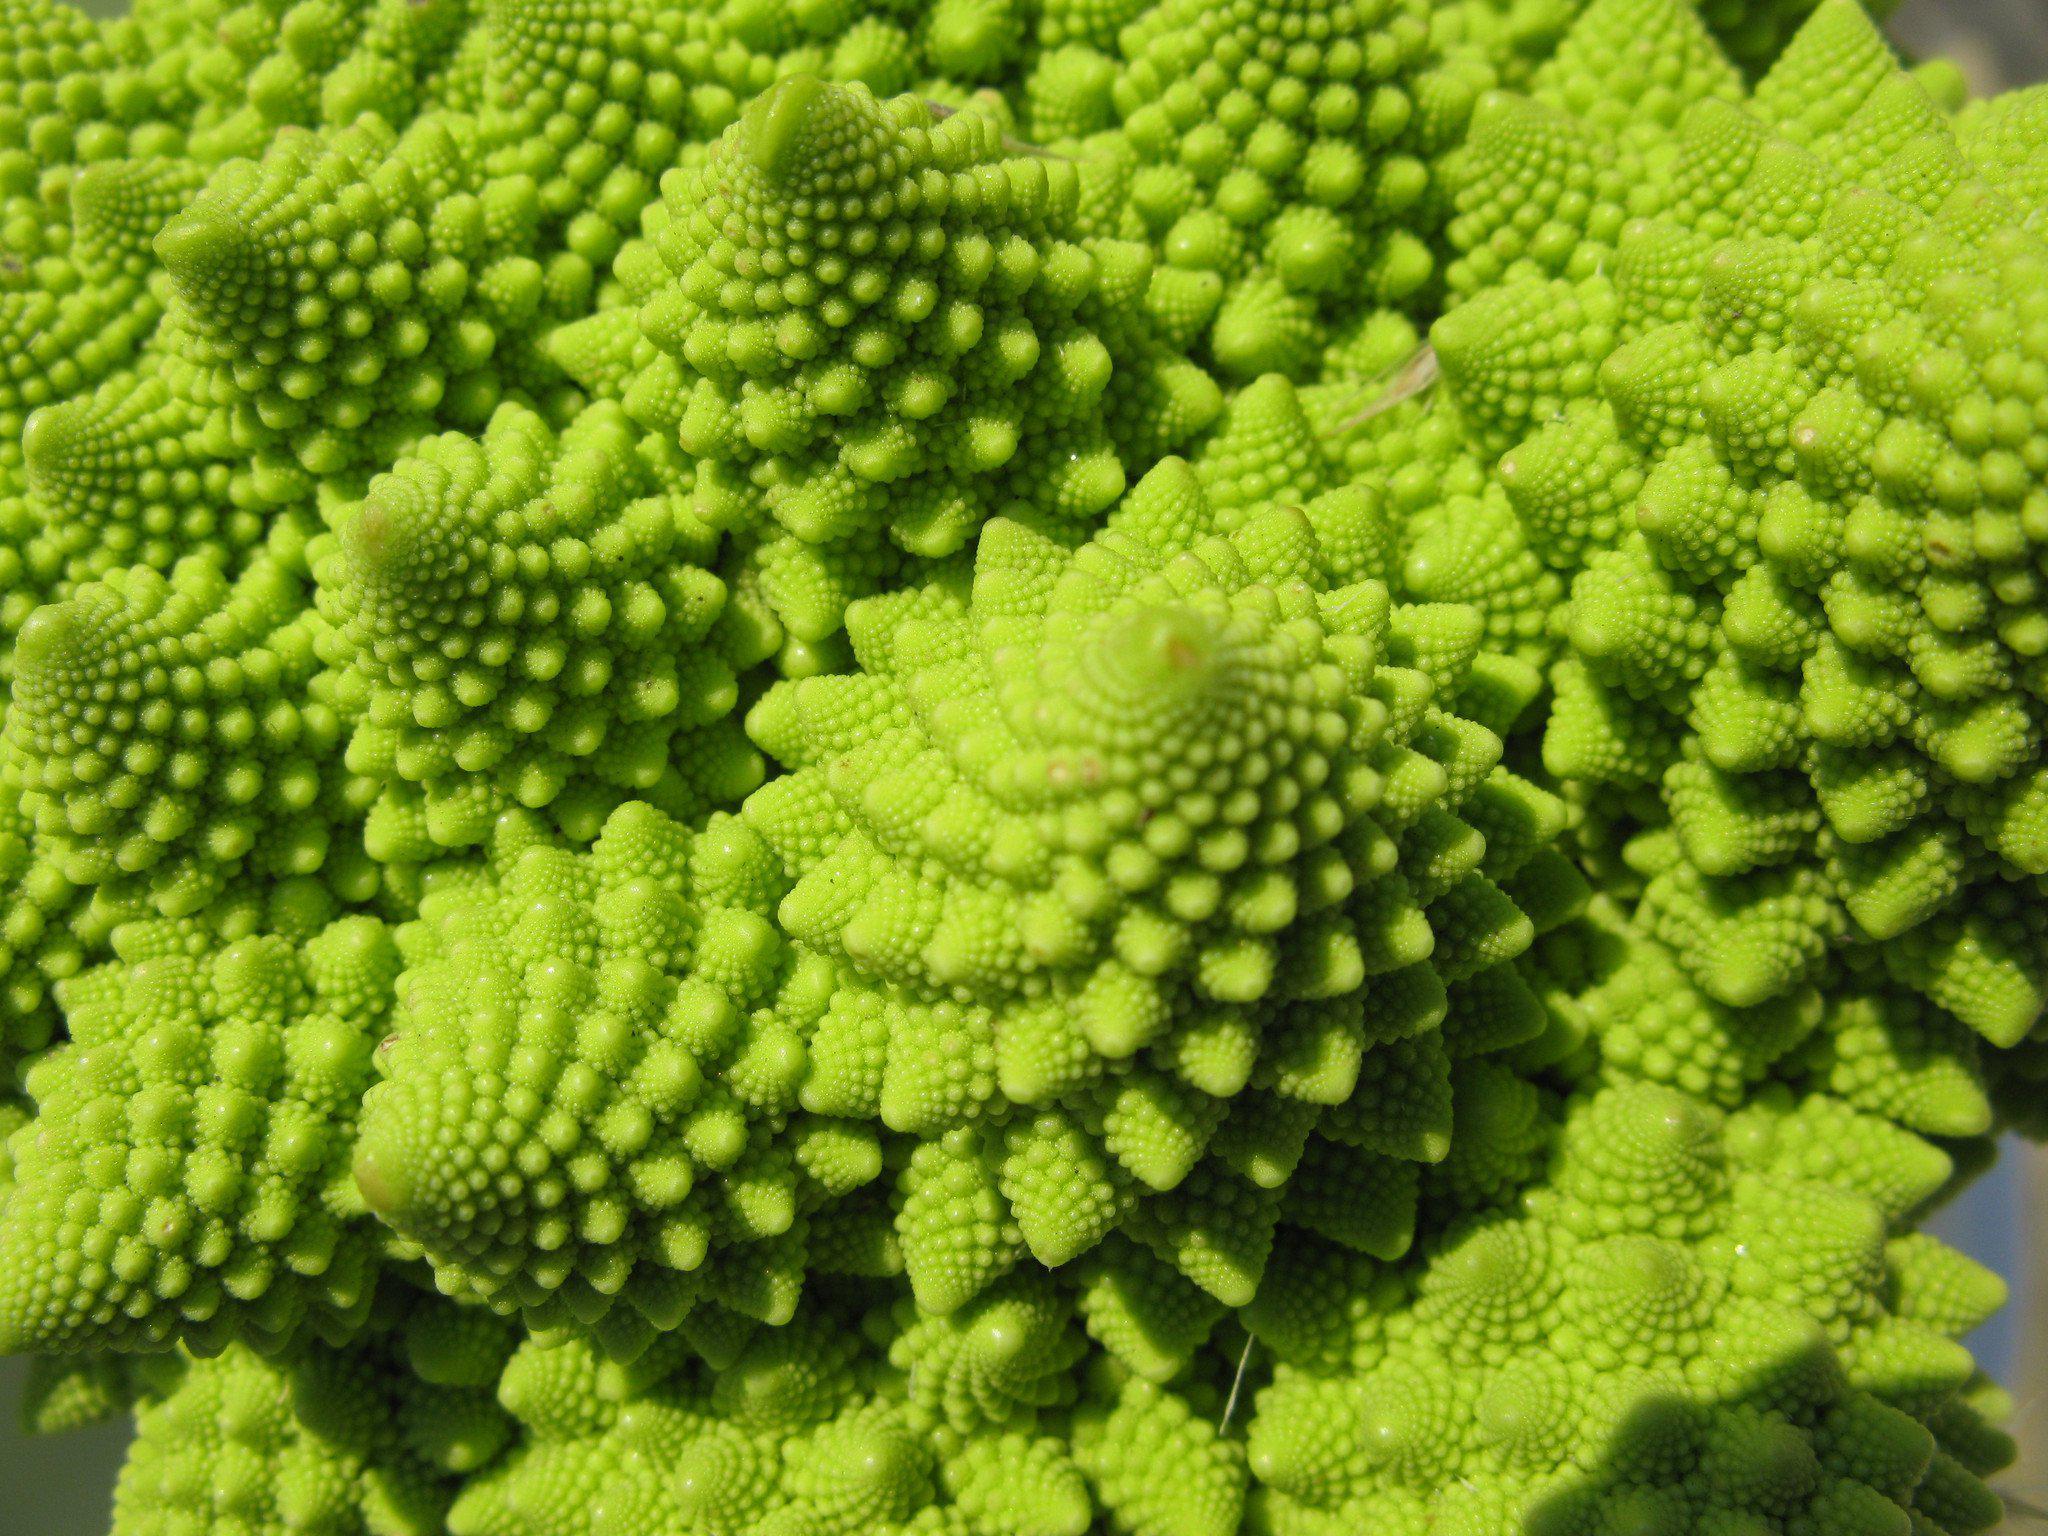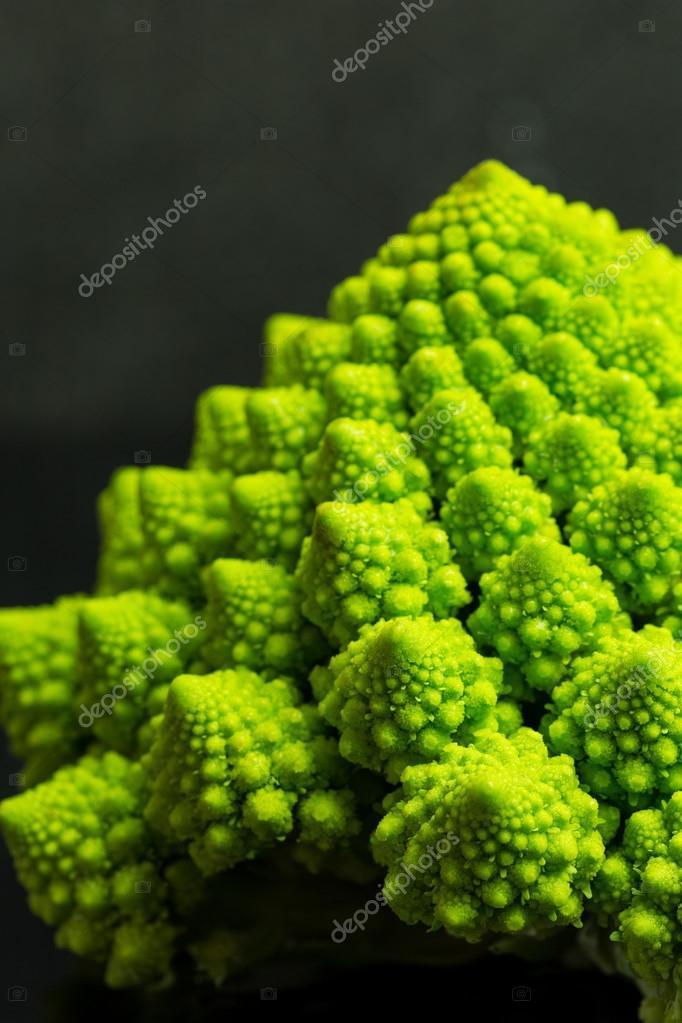The first image is the image on the left, the second image is the image on the right. Given the left and right images, does the statement "The image on the left contains cooked food." hold true? Answer yes or no. No. 